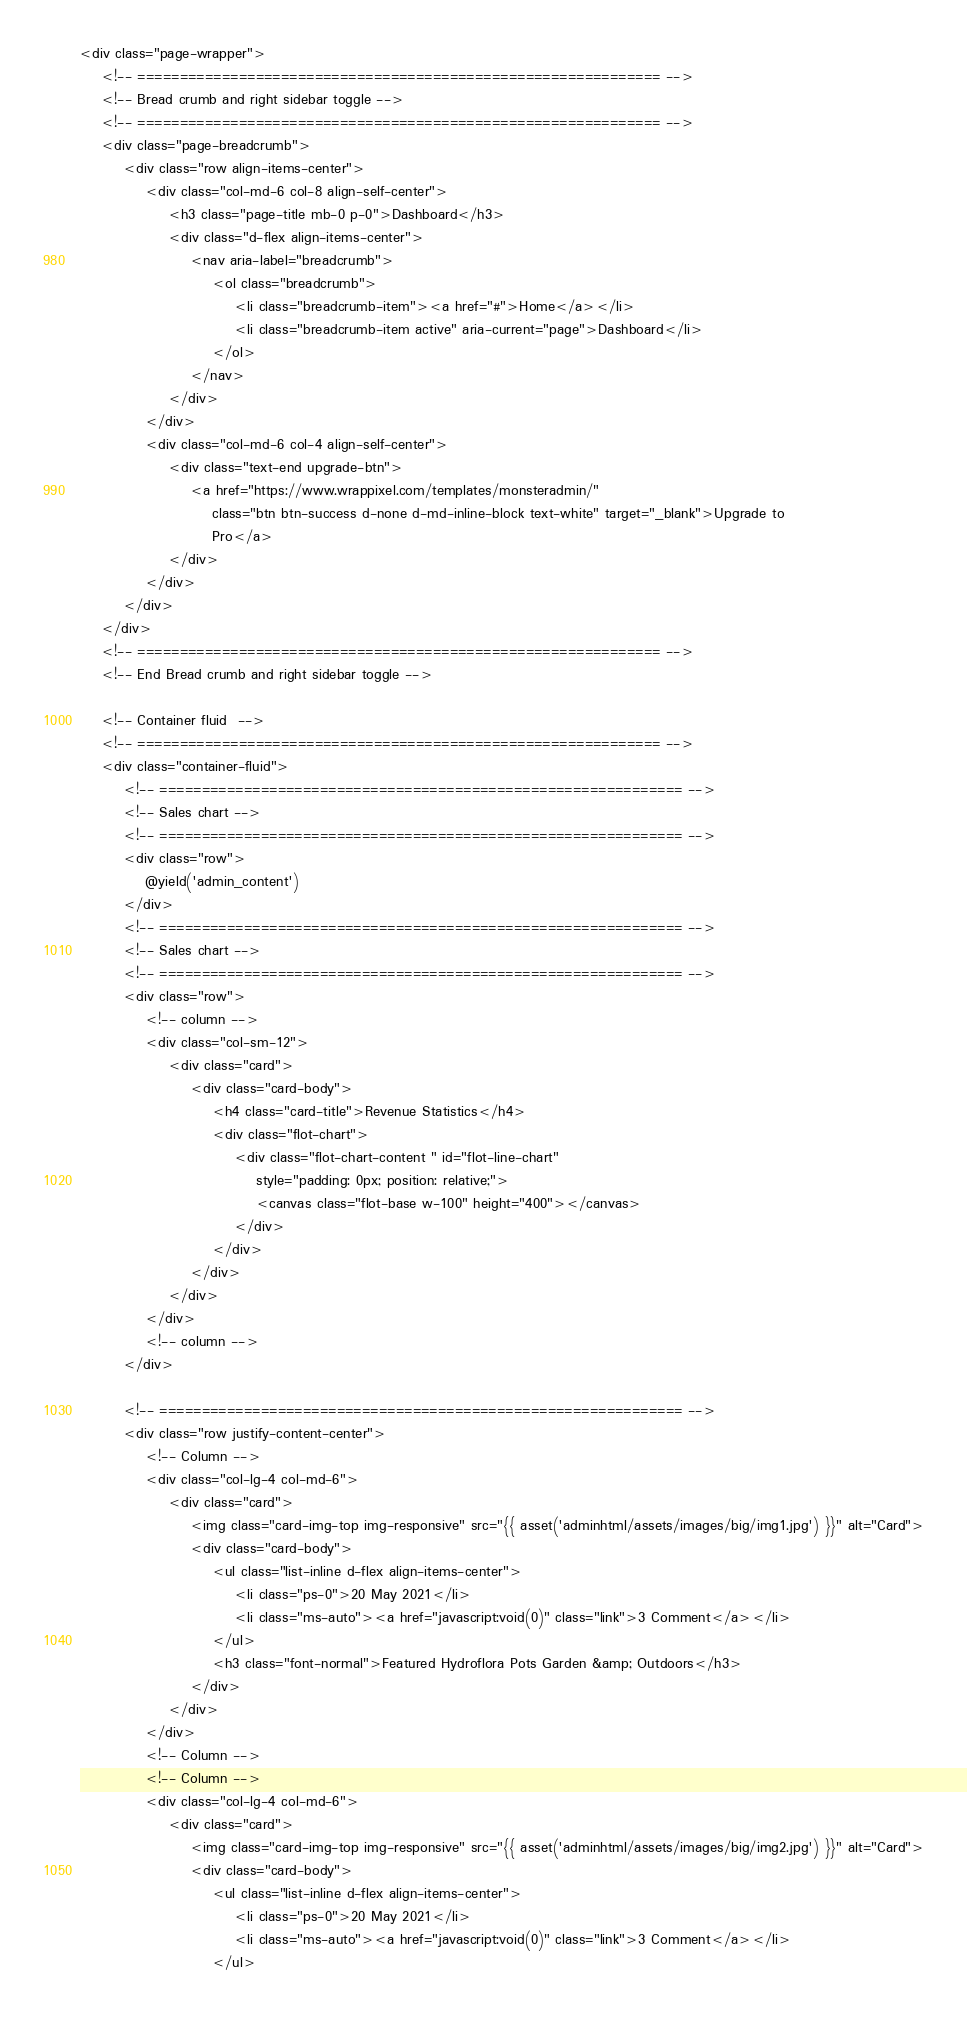Convert code to text. <code><loc_0><loc_0><loc_500><loc_500><_PHP_><div class="page-wrapper">
    <!-- ============================================================== -->
    <!-- Bread crumb and right sidebar toggle -->
    <!-- ============================================================== -->
    <div class="page-breadcrumb">
        <div class="row align-items-center">
            <div class="col-md-6 col-8 align-self-center">
                <h3 class="page-title mb-0 p-0">Dashboard</h3>
                <div class="d-flex align-items-center">
                    <nav aria-label="breadcrumb">
                        <ol class="breadcrumb">
                            <li class="breadcrumb-item"><a href="#">Home</a></li>
                            <li class="breadcrumb-item active" aria-current="page">Dashboard</li>
                        </ol>
                    </nav>
                </div>
            </div>
            <div class="col-md-6 col-4 align-self-center">
                <div class="text-end upgrade-btn">
                    <a href="https://www.wrappixel.com/templates/monsteradmin/"
                        class="btn btn-success d-none d-md-inline-block text-white" target="_blank">Upgrade to
                        Pro</a>
                </div>
            </div>
        </div>
    </div>
    <!-- ============================================================== -->
    <!-- End Bread crumb and right sidebar toggle -->
    
    <!-- Container fluid  -->
    <!-- ============================================================== -->
    <div class="container-fluid">
        <!-- ============================================================== -->
        <!-- Sales chart -->
        <!-- ============================================================== -->
        <div class="row">
            @yield('admin_content')
        </div>
        <!-- ============================================================== -->
        <!-- Sales chart -->
        <!-- ============================================================== -->
        <div class="row">
            <!-- column -->
            <div class="col-sm-12">
                <div class="card">
                    <div class="card-body">
                        <h4 class="card-title">Revenue Statistics</h4>
                        <div class="flot-chart">
                            <div class="flot-chart-content " id="flot-line-chart"
                                style="padding: 0px; position: relative;">
                                <canvas class="flot-base w-100" height="400"></canvas>
                            </div>
                        </div>
                    </div>
                </div>
            </div>
            <!-- column -->
        </div>
       
        <!-- ============================================================== -->
        <div class="row justify-content-center">
            <!-- Column -->
            <div class="col-lg-4 col-md-6">
                <div class="card">
                    <img class="card-img-top img-responsive" src="{{ asset('adminhtml/assets/images/big/img1.jpg') }}" alt="Card">
                    <div class="card-body">
                        <ul class="list-inline d-flex align-items-center">
                            <li class="ps-0">20 May 2021</li>
                            <li class="ms-auto"><a href="javascript:void(0)" class="link">3 Comment</a></li>
                        </ul>
                        <h3 class="font-normal">Featured Hydroflora Pots Garden &amp; Outdoors</h3>
                    </div>
                </div>
            </div>
            <!-- Column -->
            <!-- Column -->
            <div class="col-lg-4 col-md-6">
                <div class="card">
                    <img class="card-img-top img-responsive" src="{{ asset('adminhtml/assets/images/big/img2.jpg') }}" alt="Card">
                    <div class="card-body">
                        <ul class="list-inline d-flex align-items-center">
                            <li class="ps-0">20 May 2021</li>
                            <li class="ms-auto"><a href="javascript:void(0)" class="link">3 Comment</a></li>
                        </ul></code> 